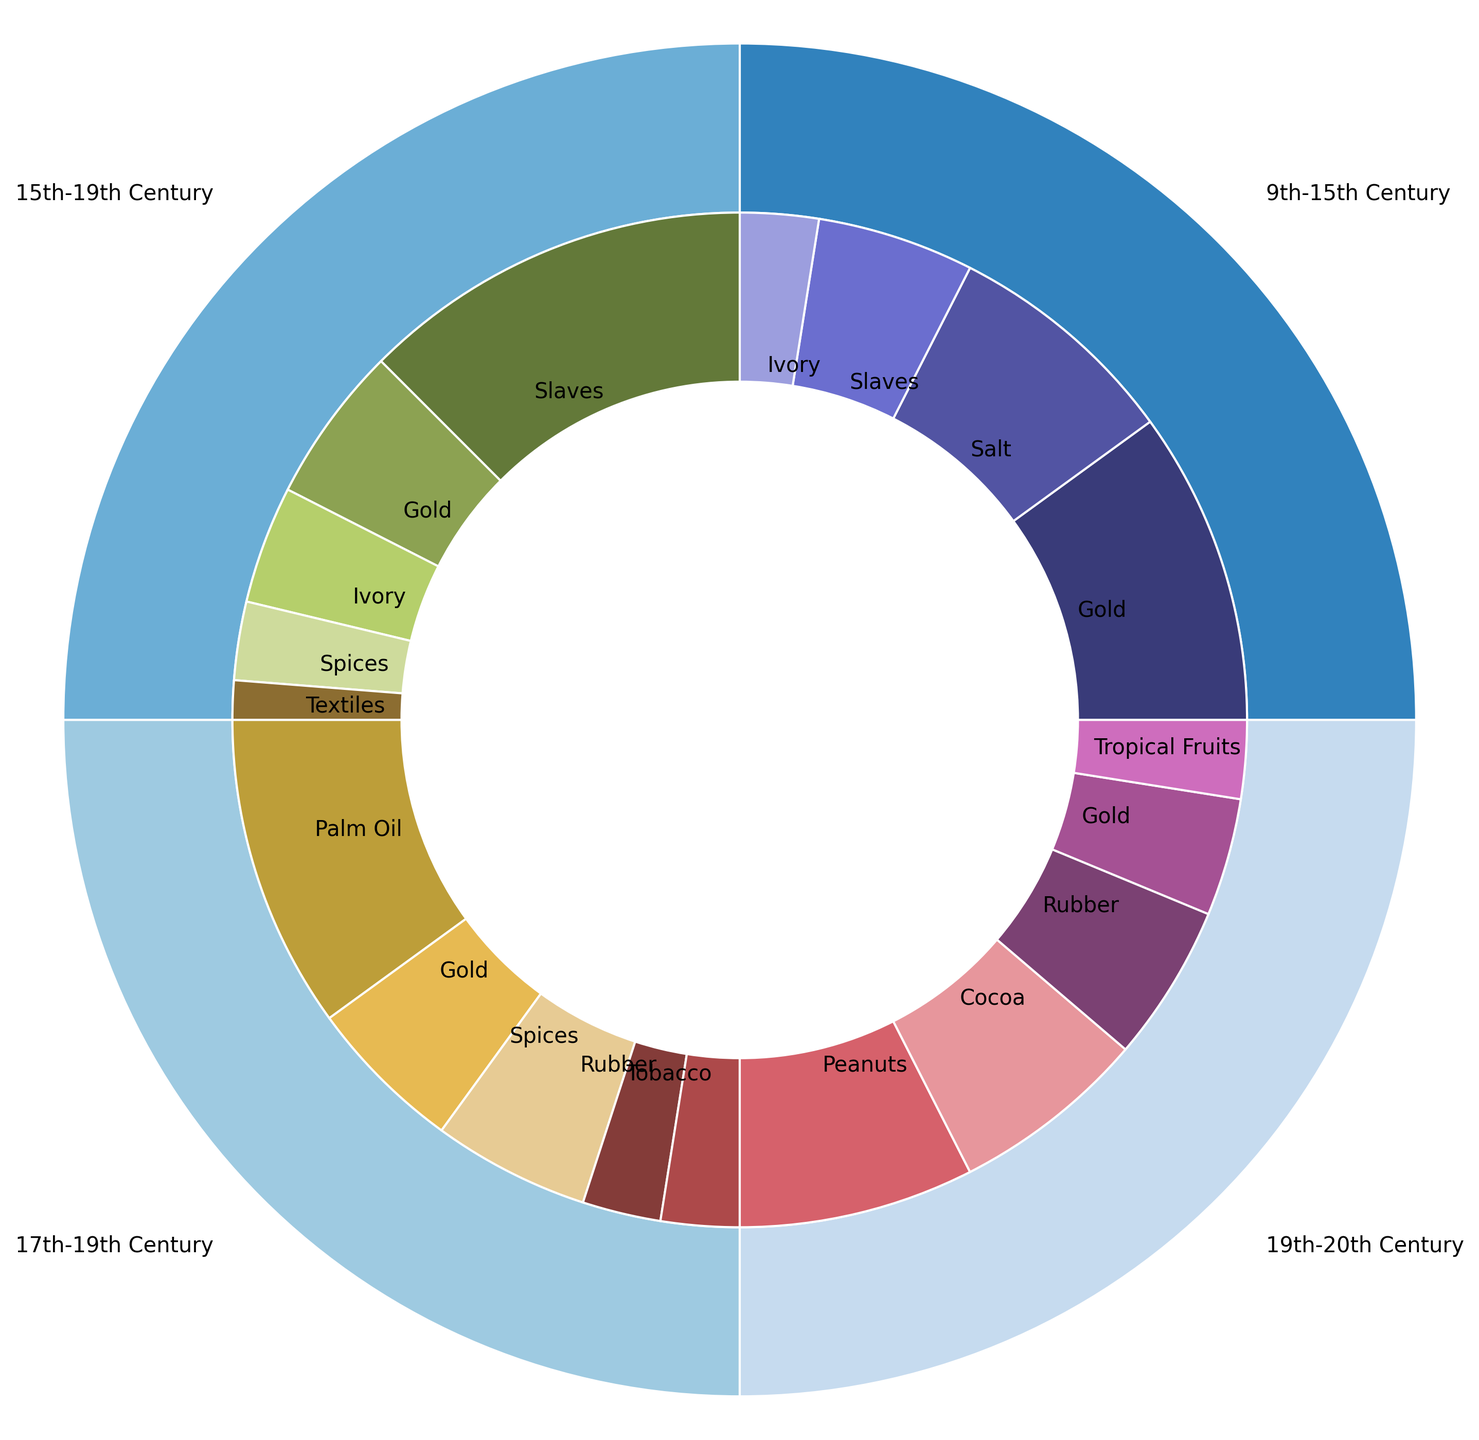What's the main good traded during the 9th-15th century on the Trans-Saharan route? The nested pie chart shows that during the 9th-15th century on the Trans-Saharan route, gold is the largest segment, indicating it's the main good traded.
Answer: Gold Which period has the highest percentage of goods traded in the Atlantic Slave Trade route? In the nested pie chart, the Atlantic Slave Trade route is observed during the 15th-19th century. To confirm, other periods do not have this route. So, the highest percentage of goods traded in this route is during the 15th-19th century.
Answer: 15th-19th Century How does the percentage of slaves traded in the Atlantic Slave Trade route compare to the Trans-Saharan route? The chart shows 50% of goods traded are slaves in the Atlantic Slave Trade route (15th-19th century) and 20% in the Trans-Saharan route (9th-15th century).
Answer: Higher in the Atlantic Slave Trade What percentage of trade is accounted for by palm oil in the 17th-19th century British Trade? The segment representing palm oil in the 17th-19th century British Trade shows 40%, which can be directly read from the chart.
Answer: 40% During the 19th-20th century colonial era, what are the percentages of peanuts and rubber traded? In the nested pie chart, peanuts are 30% and rubber is 20% in the 19th-20th century colonial era as indicated by their respective segments.
Answer: Peanuts: 30%, Rubber: 20% Which time period shows the most diverse range of goods traded and what are they? The 19th-20th century (Colonial Era) shows five different goods: peanuts, cocoa, rubber, gold, and tropical fruits, the most diverse range.
Answer: 19th-20th Century, Peanuts, Cocoa, Rubber, Gold, Tropical Fruits Compare the total trade of gold between the 15th-19th century Atlantic Slave Trade and 17th-19th century British Trade. In the Atlantic Slave Trade, gold is at 20%, and in the British Trade, it's also 20%. Total trade percentage of gold is equal in both periods.
Answer: Equal What is the second most traded good in the 9th-15th century on the Trans-Saharan route? Visually identifying the segments and their sizes in this period, salt, with 30%, is second after gold.
Answer: Salt How much more cocoa is traded than tropical fruits during the 19th-20th century colonial era? During the 19th-20th century colonial era, cocoa is 25% and tropical fruits are 10%. The difference is 25% - 10% = 15%.
Answer: 15% Identify the periods with the highest and lowest trading share of slaves. The Atlantic Slave Trade (15th-19th century) has the highest at 50%, while the Trans-Saharan route (9th-15th century) has the lowest at 20%.
Answer: Highest: 15th-19th Century, Lowest: 9th-15th Century 